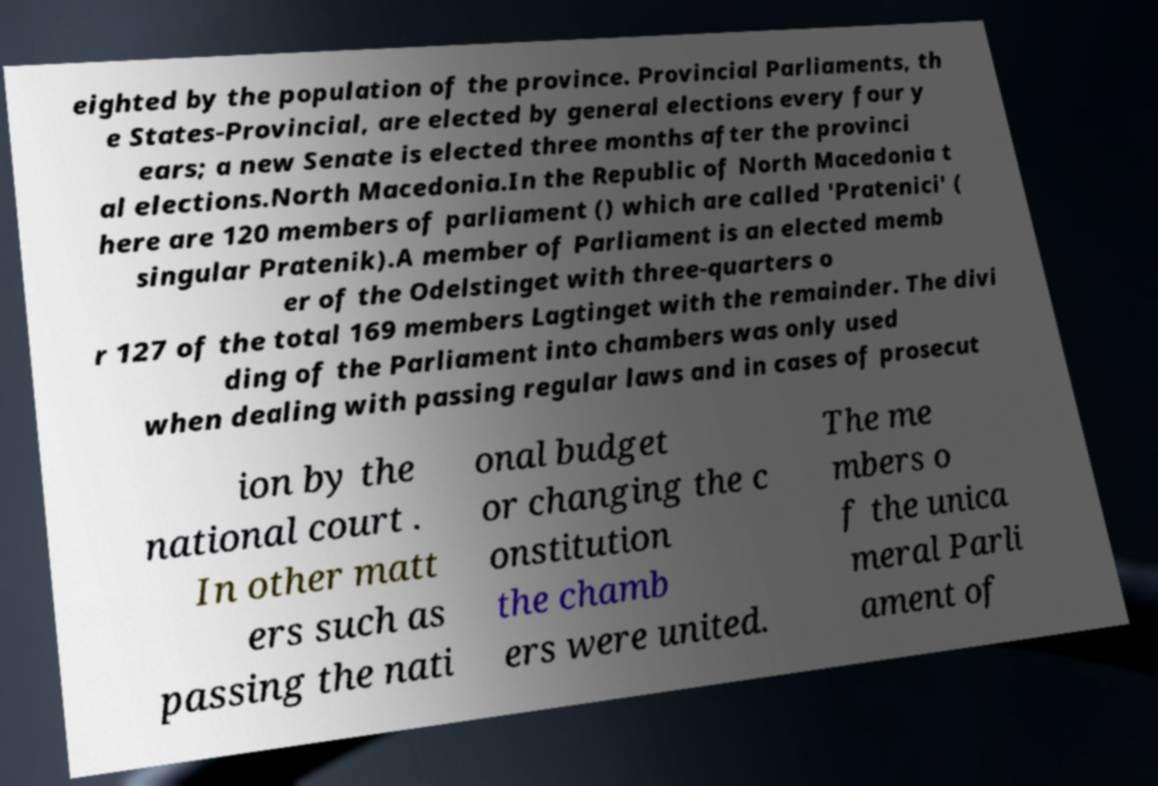Please identify and transcribe the text found in this image. eighted by the population of the province. Provincial Parliaments, th e States-Provincial, are elected by general elections every four y ears; a new Senate is elected three months after the provinci al elections.North Macedonia.In the Republic of North Macedonia t here are 120 members of parliament () which are called 'Pratenici' ( singular Pratenik).A member of Parliament is an elected memb er of the Odelstinget with three-quarters o r 127 of the total 169 members Lagtinget with the remainder. The divi ding of the Parliament into chambers was only used when dealing with passing regular laws and in cases of prosecut ion by the national court . In other matt ers such as passing the nati onal budget or changing the c onstitution the chamb ers were united. The me mbers o f the unica meral Parli ament of 